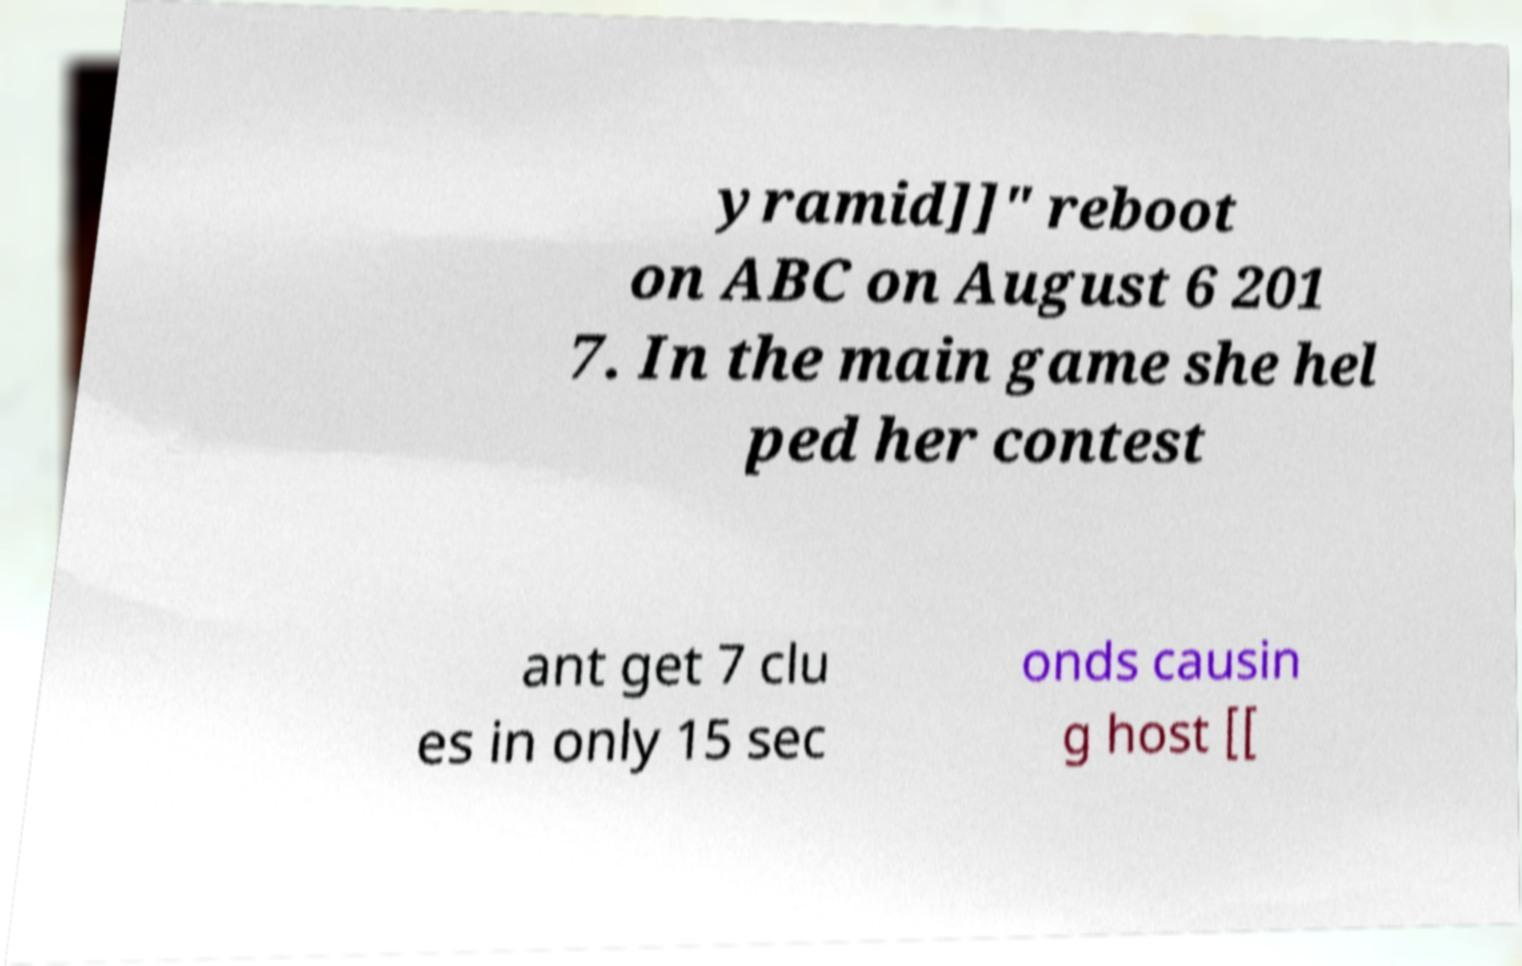I need the written content from this picture converted into text. Can you do that? yramid]]" reboot on ABC on August 6 201 7. In the main game she hel ped her contest ant get 7 clu es in only 15 sec onds causin g host [[ 